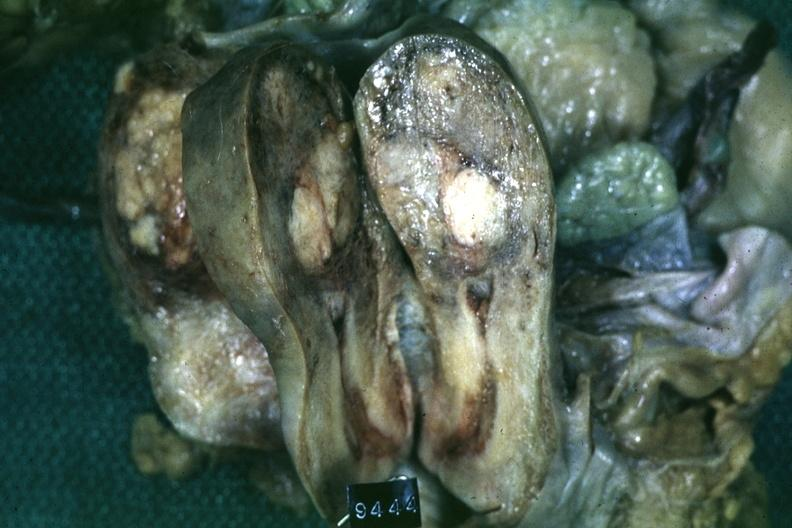what does this image show?
Answer the question using a single word or phrase. Fixed tissue saggital section of organ with cross sectioned myoma 